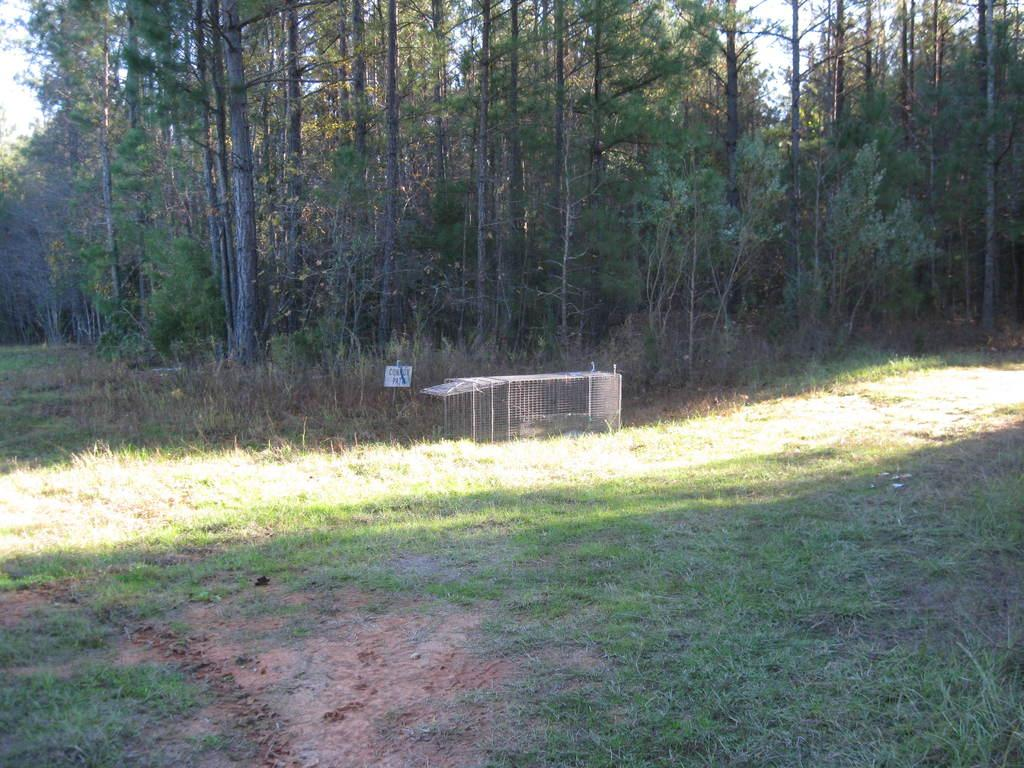What is located in the center of the image? There is a mesh in the center of the image. What type of vegetation is at the bottom of the image? There is grass at the bottom of the image. What can be seen in the background of the image? There are trees and the sky visible in the background of the image. What is the condition of the crib in the image? There is no crib present in the image. Can you describe the play area in the image? There is no play area mentioned in the provided facts, as the image only contains a mesh, grass, trees, and the sky. 